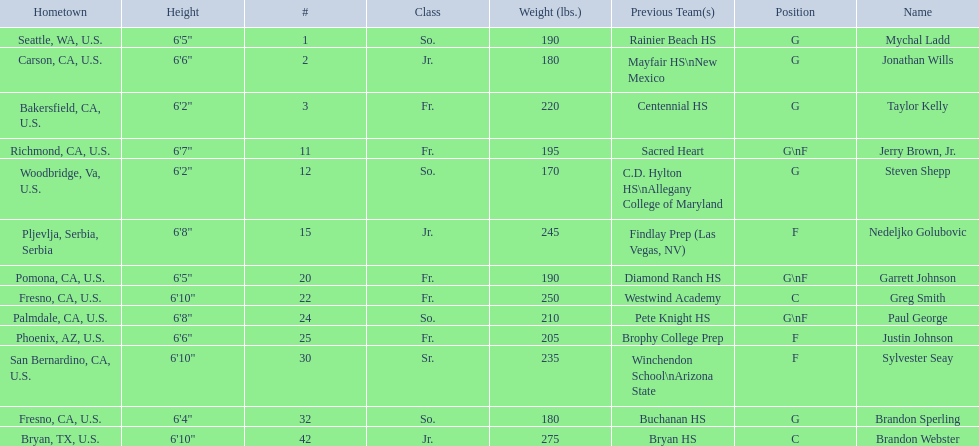Which players are forwards? Nedeljko Golubovic, Paul George, Justin Johnson, Sylvester Seay. What are the heights of these players? Nedeljko Golubovic, 6'8", Paul George, 6'8", Justin Johnson, 6'6", Sylvester Seay, 6'10". Of these players, who is the shortest? Justin Johnson. 